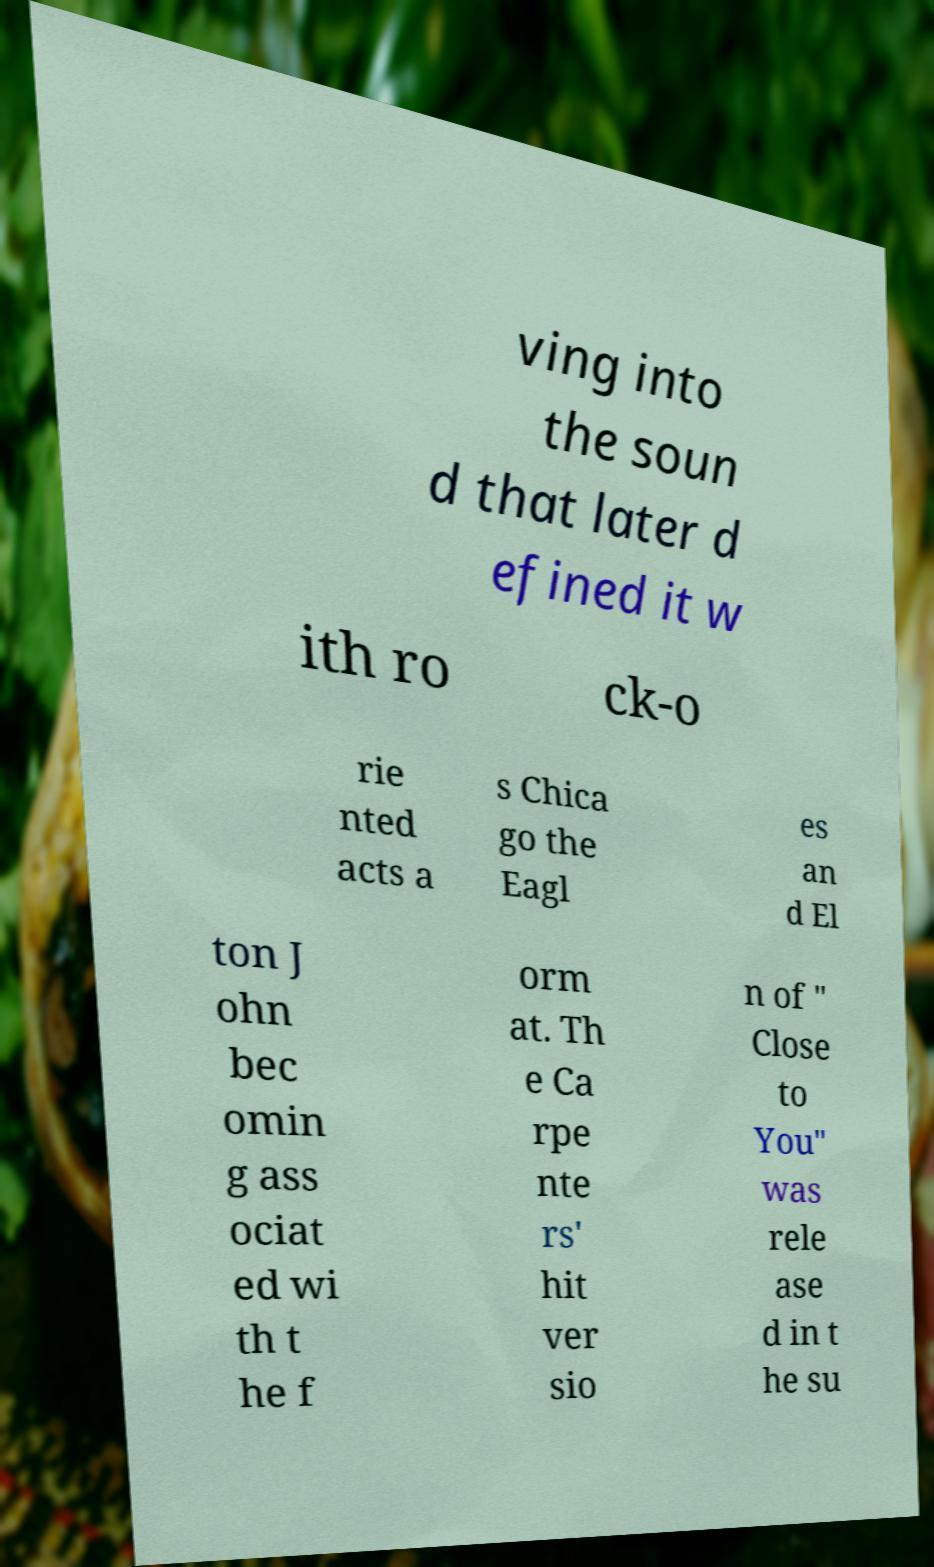Please identify and transcribe the text found in this image. ving into the soun d that later d efined it w ith ro ck-o rie nted acts a s Chica go the Eagl es an d El ton J ohn bec omin g ass ociat ed wi th t he f orm at. Th e Ca rpe nte rs' hit ver sio n of " Close to You" was rele ase d in t he su 